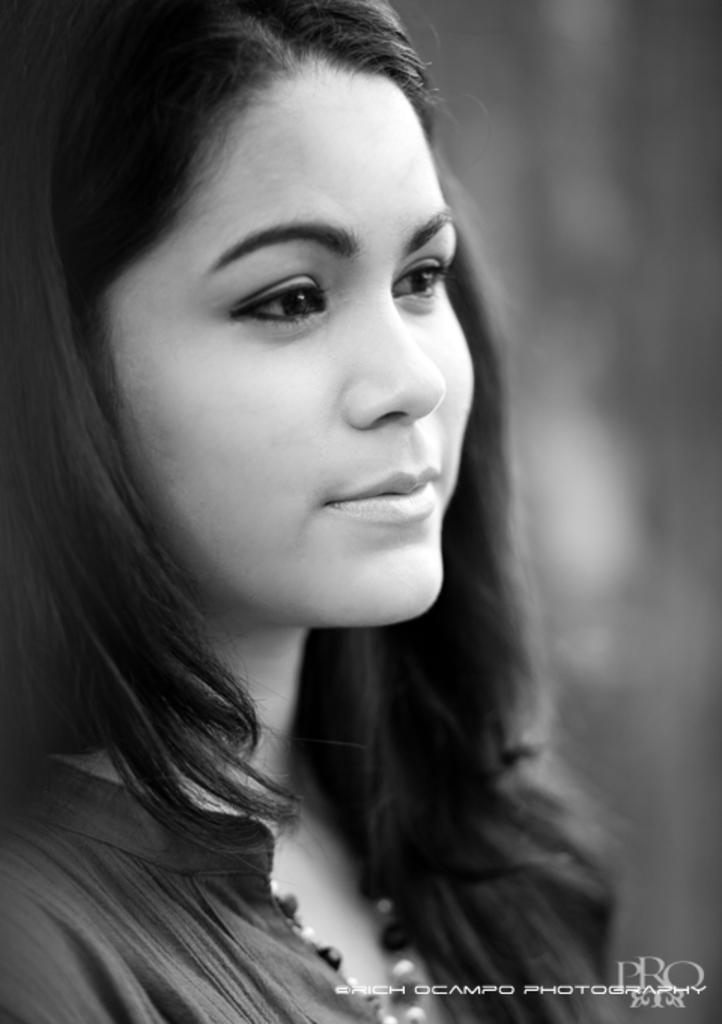Can you describe this image briefly? In the picture there is a woman, on the poster there is a watermark present. 